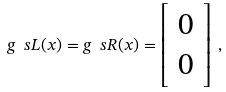Convert formula to latex. <formula><loc_0><loc_0><loc_500><loc_500>g ^ { \ } s L ( x ) = g ^ { \ } s R ( x ) = \left [ \begin{array} { c } 0 \\ 0 \end{array} \right ] \, ,</formula> 